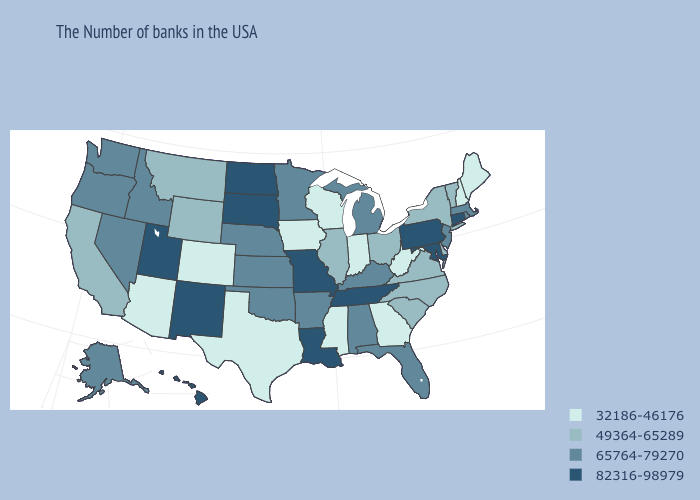Does Louisiana have the highest value in the South?
Quick response, please. Yes. Among the states that border Nebraska , which have the lowest value?
Concise answer only. Iowa, Colorado. Does South Carolina have the highest value in the South?
Be succinct. No. Does the first symbol in the legend represent the smallest category?
Be succinct. Yes. What is the highest value in the USA?
Write a very short answer. 82316-98979. Name the states that have a value in the range 49364-65289?
Keep it brief. Vermont, New York, Delaware, Virginia, North Carolina, South Carolina, Ohio, Illinois, Wyoming, Montana, California. Name the states that have a value in the range 49364-65289?
Be succinct. Vermont, New York, Delaware, Virginia, North Carolina, South Carolina, Ohio, Illinois, Wyoming, Montana, California. What is the lowest value in states that border Louisiana?
Give a very brief answer. 32186-46176. What is the value of Virginia?
Be succinct. 49364-65289. Name the states that have a value in the range 32186-46176?
Quick response, please. Maine, New Hampshire, West Virginia, Georgia, Indiana, Wisconsin, Mississippi, Iowa, Texas, Colorado, Arizona. What is the highest value in the West ?
Quick response, please. 82316-98979. Name the states that have a value in the range 32186-46176?
Write a very short answer. Maine, New Hampshire, West Virginia, Georgia, Indiana, Wisconsin, Mississippi, Iowa, Texas, Colorado, Arizona. What is the highest value in the MidWest ?
Keep it brief. 82316-98979. Name the states that have a value in the range 49364-65289?
Quick response, please. Vermont, New York, Delaware, Virginia, North Carolina, South Carolina, Ohio, Illinois, Wyoming, Montana, California. How many symbols are there in the legend?
Give a very brief answer. 4. 